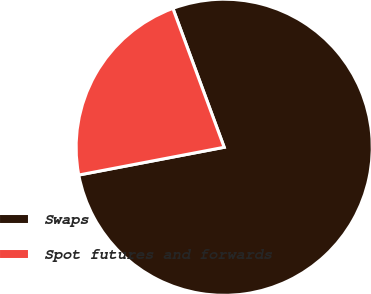<chart> <loc_0><loc_0><loc_500><loc_500><pie_chart><fcel>Swaps<fcel>Spot futures and forwards<nl><fcel>77.63%<fcel>22.37%<nl></chart> 